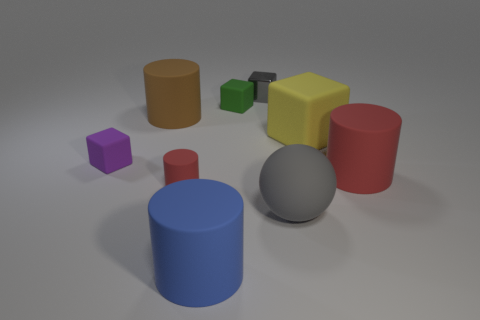How many red cylinders must be subtracted to get 1 red cylinders? 1 Subtract all large rubber cylinders. How many cylinders are left? 1 Subtract all red cylinders. How many cylinders are left? 2 Subtract 1 blocks. How many blocks are left? 3 Subtract all brown cubes. How many red cylinders are left? 2 Subtract all blocks. How many objects are left? 5 Add 1 large matte things. How many objects exist? 10 Subtract all red cylinders. Subtract all green cubes. How many cylinders are left? 2 Subtract all large matte balls. Subtract all brown objects. How many objects are left? 7 Add 4 big yellow rubber objects. How many big yellow rubber objects are left? 5 